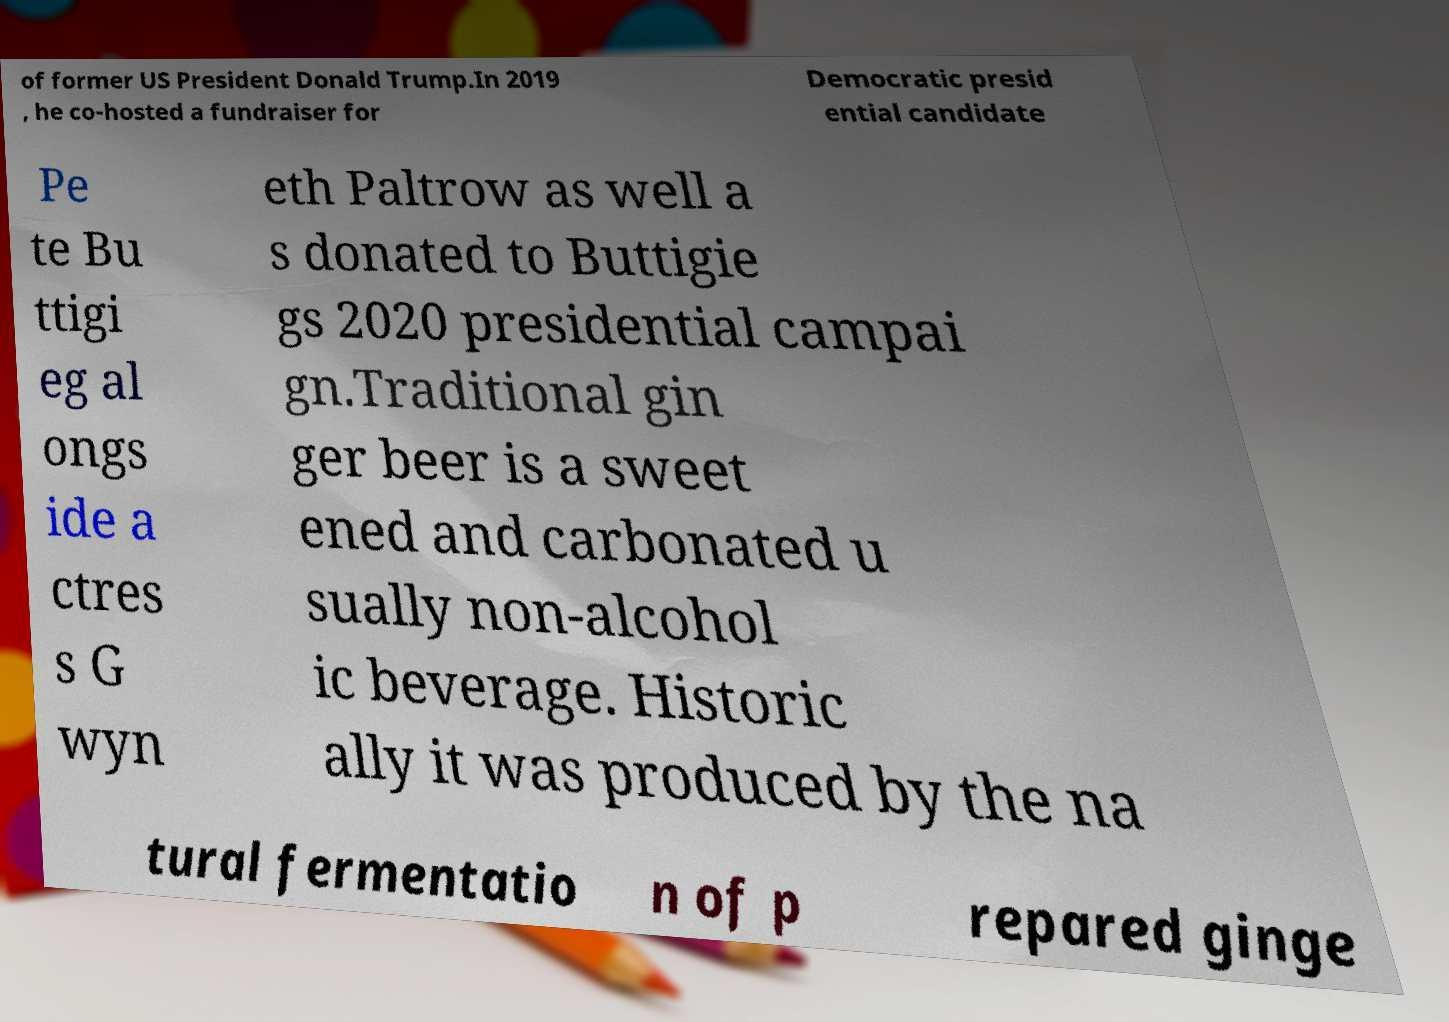Please identify and transcribe the text found in this image. of former US President Donald Trump.In 2019 , he co-hosted a fundraiser for Democratic presid ential candidate Pe te Bu ttigi eg al ongs ide a ctres s G wyn eth Paltrow as well a s donated to Buttigie gs 2020 presidential campai gn.Traditional gin ger beer is a sweet ened and carbonated u sually non-alcohol ic beverage. Historic ally it was produced by the na tural fermentatio n of p repared ginge 